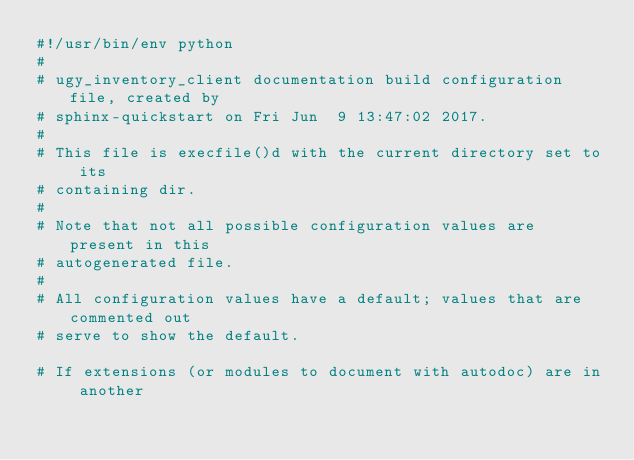<code> <loc_0><loc_0><loc_500><loc_500><_Python_>#!/usr/bin/env python
#
# ugy_inventory_client documentation build configuration file, created by
# sphinx-quickstart on Fri Jun  9 13:47:02 2017.
#
# This file is execfile()d with the current directory set to its
# containing dir.
#
# Note that not all possible configuration values are present in this
# autogenerated file.
#
# All configuration values have a default; values that are commented out
# serve to show the default.

# If extensions (or modules to document with autodoc) are in another</code> 